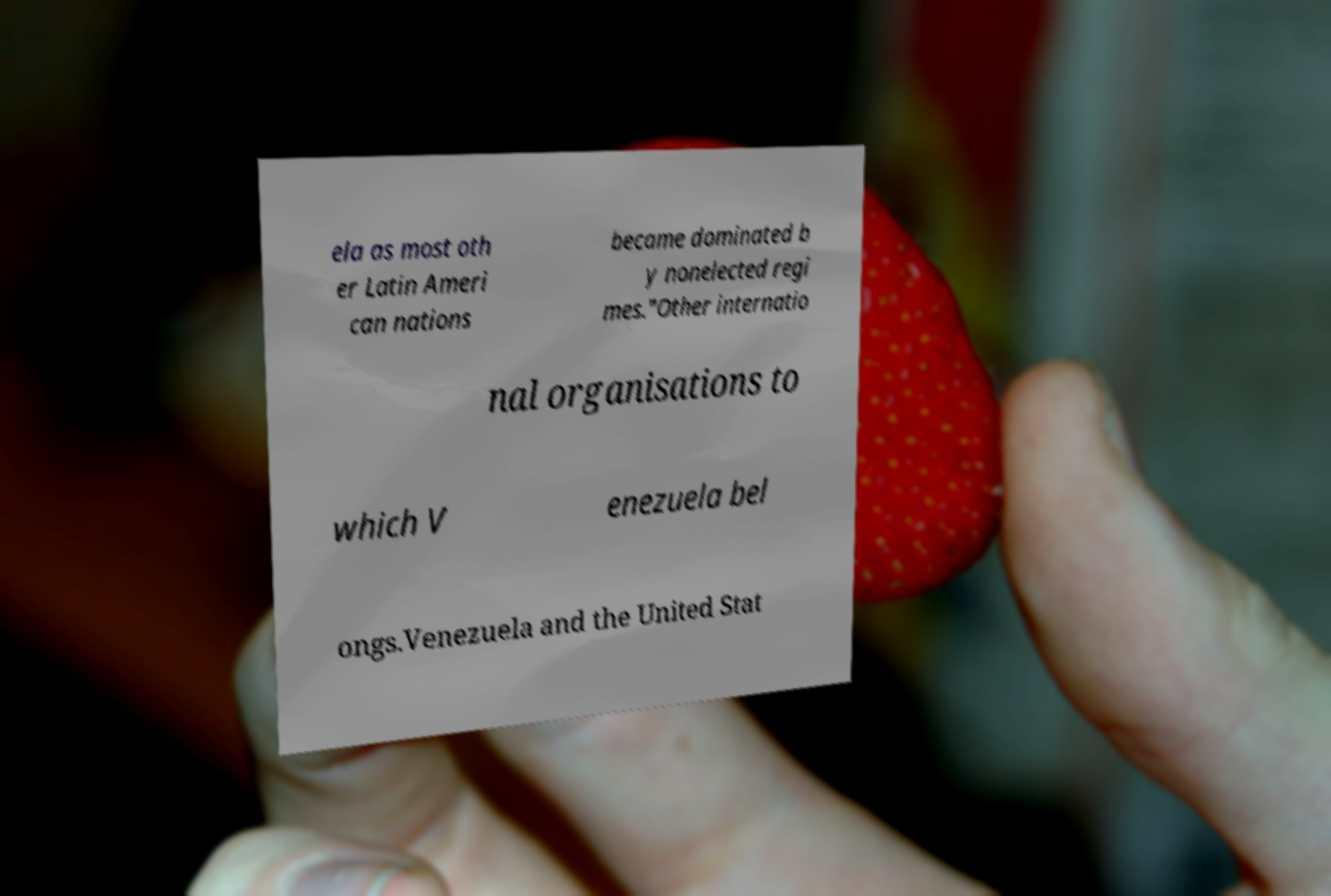Please identify and transcribe the text found in this image. ela as most oth er Latin Ameri can nations became dominated b y nonelected regi mes."Other internatio nal organisations to which V enezuela bel ongs.Venezuela and the United Stat 